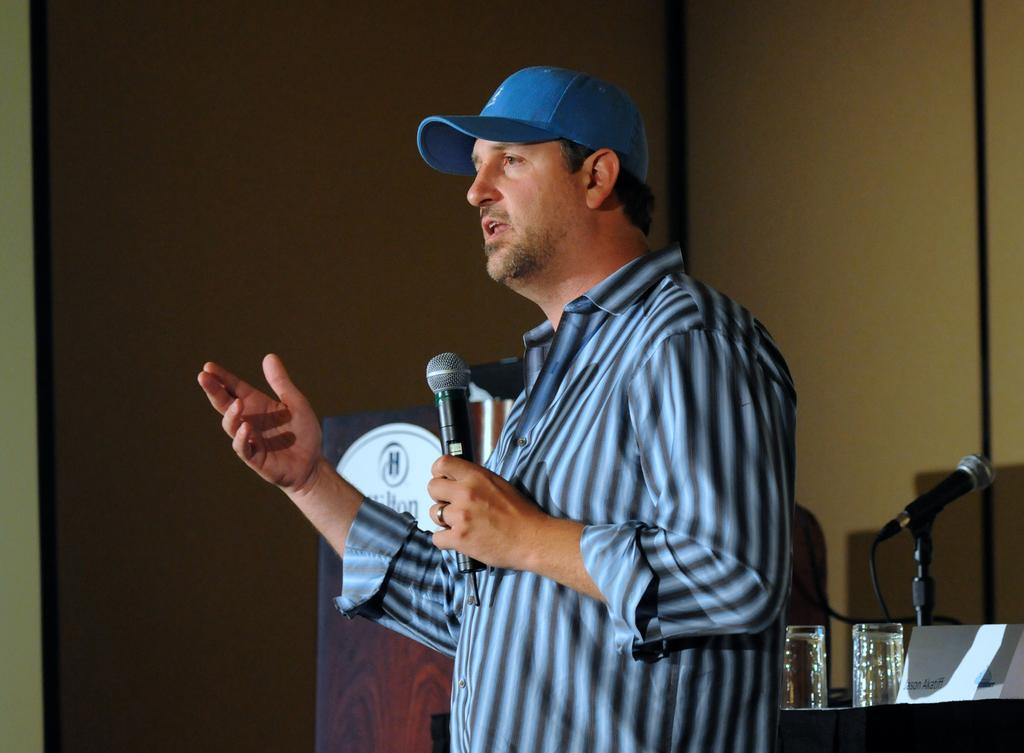What is the main subject of the image? There is a man in the middle of the image. Can you describe the man's attire? The man is wearing a shirt and a cap. What is the man doing in the image? The man is speaking and holding a microphone. What can be seen in the background of the image? There is a table with glasses on it, another microphone, and a wall. What type of meat is being served in a bowl of soup in the image? There is no bowl of soup or meat present in the image. What is the limit of the man's speaking abilities in the image? The image does not provide information about the man's speaking abilities or any limits on them. 